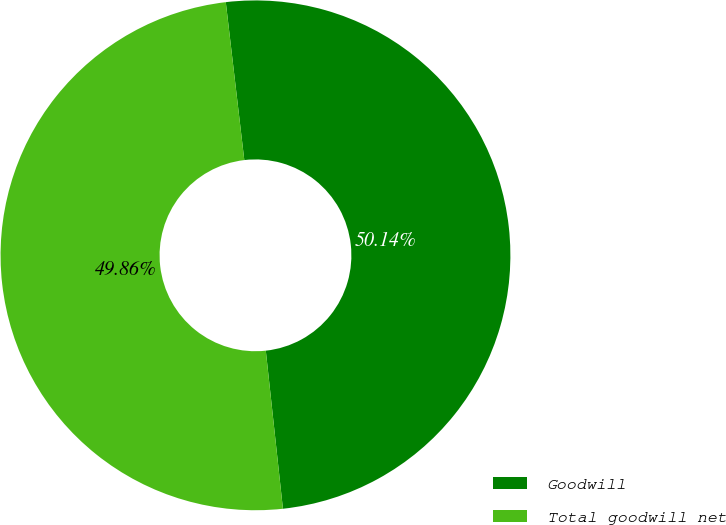<chart> <loc_0><loc_0><loc_500><loc_500><pie_chart><fcel>Goodwill<fcel>Total goodwill net<nl><fcel>50.14%<fcel>49.86%<nl></chart> 